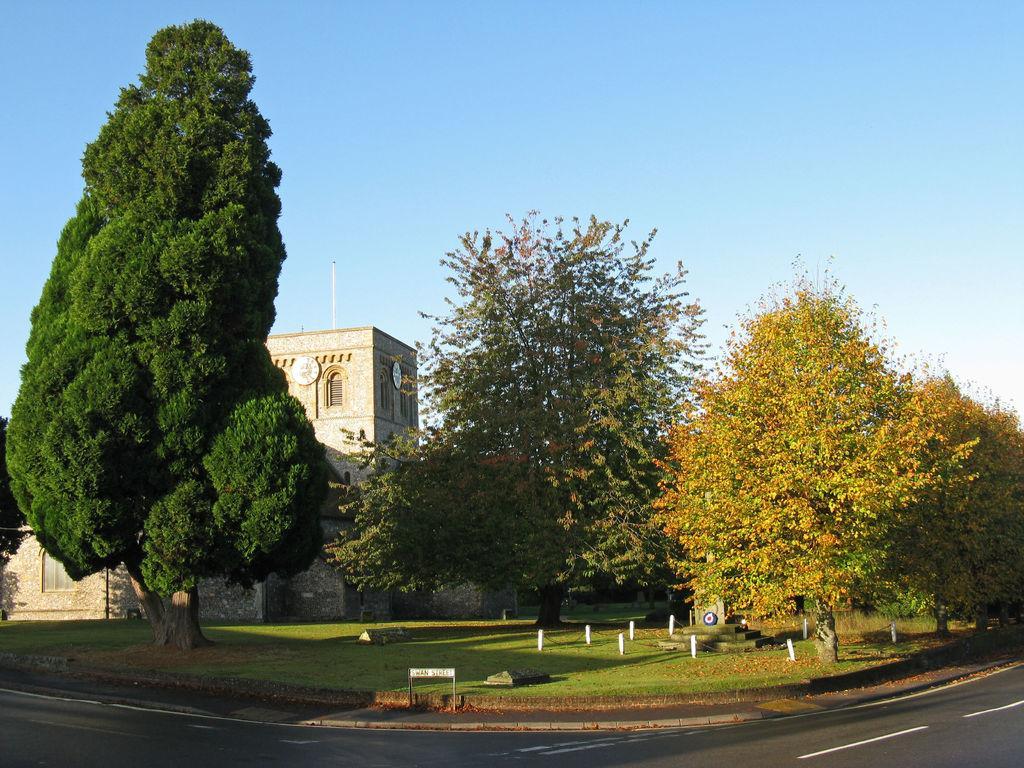Can you describe this image briefly? In this image I can see number of trees, grass, shadows, white lines on road, a building and the sky in background. 